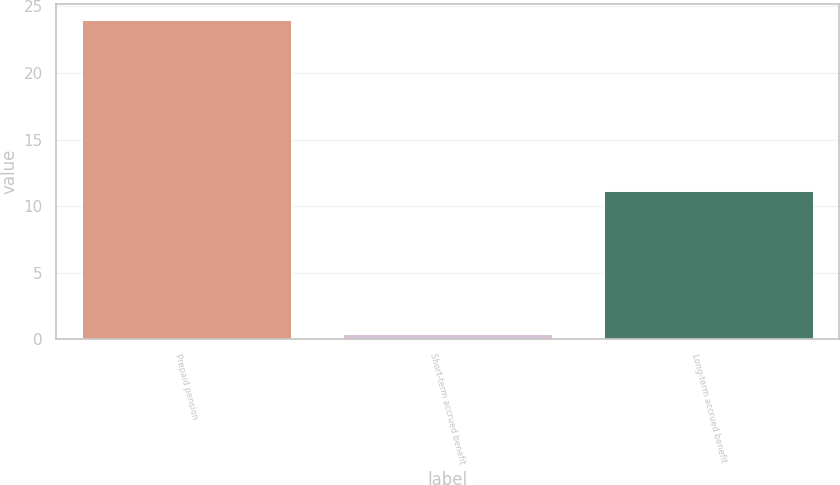Convert chart to OTSL. <chart><loc_0><loc_0><loc_500><loc_500><bar_chart><fcel>Prepaid pension<fcel>Short-term accrued benefit<fcel>Long-term accrued benefit<nl><fcel>24<fcel>0.4<fcel>11.1<nl></chart> 